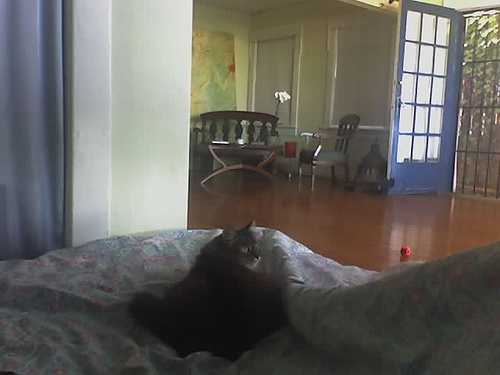Describe the objects in this image and their specific colors. I can see bed in gray, black, and darkgray tones, cat in gray and black tones, chair in gray and black tones, and potted plant in gray and black tones in this image. 